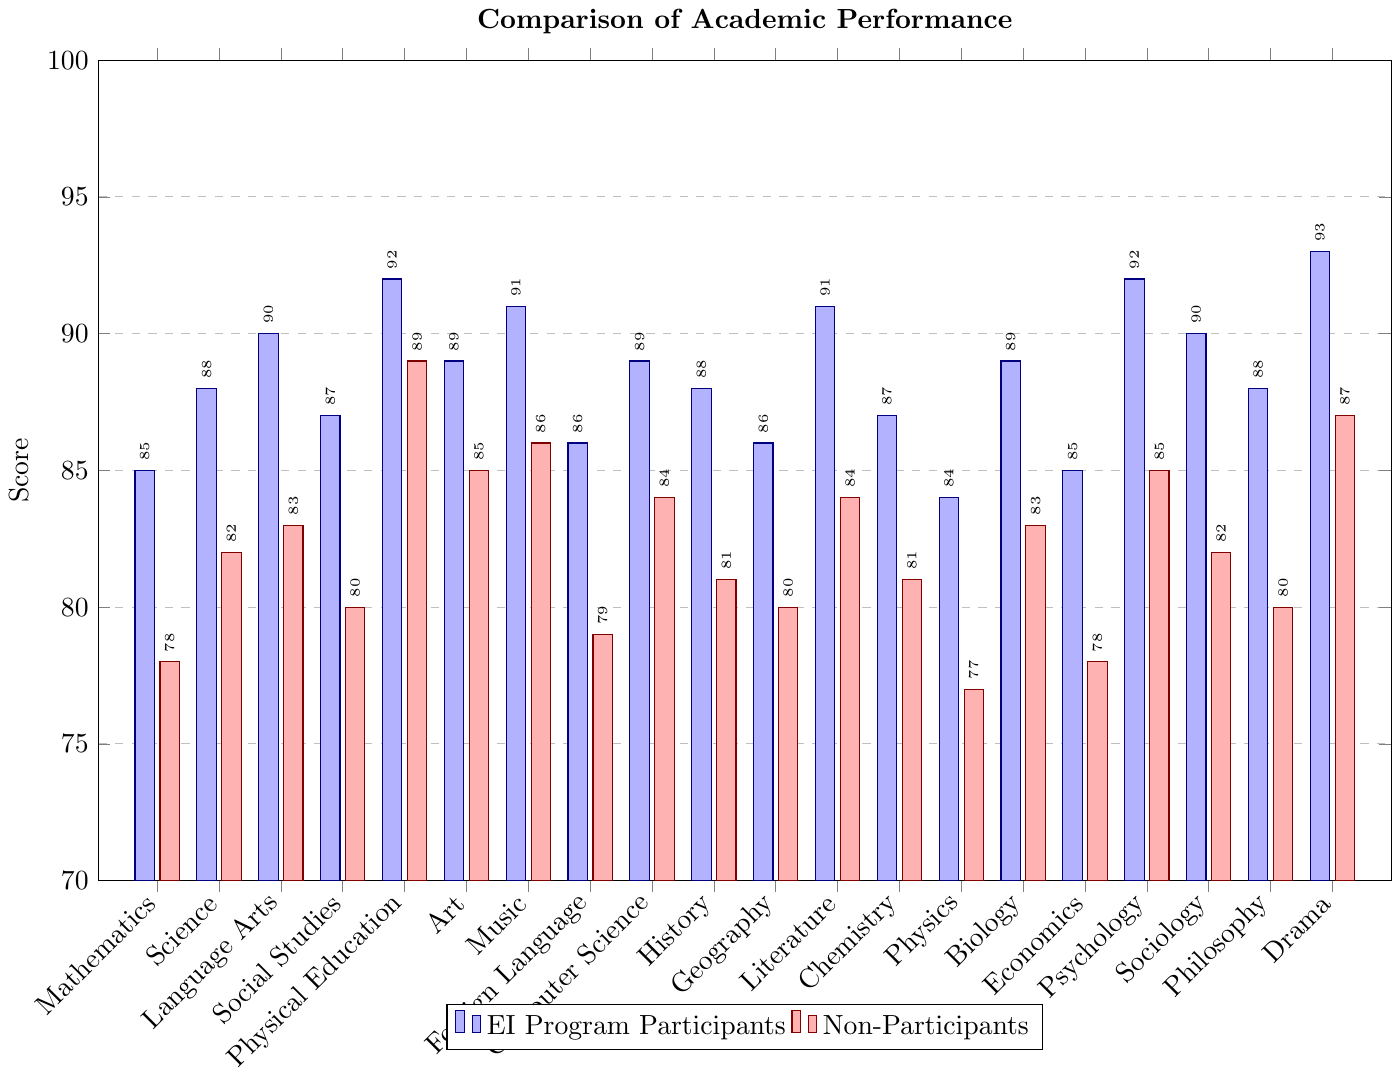What subject shows the biggest performance difference between EI Program Participants and Non-Participants? Subtract the scores of Non-Participants from those of EI Program Participants for each subject and find the maximum difference. The biggest difference is 7 in Mathematics (85 - 78 = 7).
Answer: Mathematics Which subject have EI Program Participants and Non-Participants closest average scores? Calculate the differences for each subject and find the minimum. Drama has the smallest difference of 6 (93 - 87).
Answer: Drama What is the overall average score of EI Program Participants in all subjects? Add all scores of EI Program Participants and divide by the number of subjects. The total is 1786 and there are 20 subjects, so the average is 1786 / 20 = 89.3.
Answer: 89.3 In which subjects do Non-Participants outperform EI Program Participants? Compare the scores in each subject where Non-Participants' score is higher. There are no such subjects in the data provided.
Answer: None Which subjects show a performance difference of 5 points or more between EI Program Participants and Non-Participants? Calculate the differences and check where it is 5 or more. These subjects are Mathematics (7), Science (6), Language Arts (7), Social Studies (7), Foreign Language (7), Computer Science (5), History (7), Literature (7), Physics (7), Chemistry (6), Biology (6), Economics (7), Sociology (8), Philosophy (8), Drama (6).
Answer: Mathematics, Science, Language Arts, Social Studies, Foreign Language, Computer Science, History, Literature, Chemistry, Physics, Biology, Economics, Sociology, Philosophy, Drama How many subjects have EI Program Participants scoring above 90? Count the number of subjects where EI Program Participants' scores are greater than 90. These subjects are Physical Education, Music, Psychology, Literature, Drama.
Answer: 5 What is the average score difference between EI Program Participants and Non-Participants? Calculate the total difference by subtracting Non-Participants' scores from EI Program Participants' scores in each subject, adding these differences together, then dividing by the number of subjects. The total difference is 146, so the average difference is 146 / 20 = 7.3.
Answer: 7.3 Which group scores higher in Physical Education? Compare the height of the bars for Physical Education. EI Program Participants (92) score higher than Non-Participants (89).
Answer: EI Program Participants What is the total score for Non-Participants in Art, Music, and Drama combined? Add the scores of Non-Participants in these subjects: Art (85), Music (86), Drama (87). The total is 85 + 86 + 87 = 258.
Answer: 258 What is the median score of EI Program Participants? Sort the scores and find the middle value. The sorted scores are 84, 85, 85, 86, 86, 87, 87, 88, 88, 88, 89, 89, 89, 90, 90, 91, 91, 92, 92, 93. The median is the average of the 10th and 11th scores: (88 + 89) / 2 = 88.5.
Answer: 88.5 